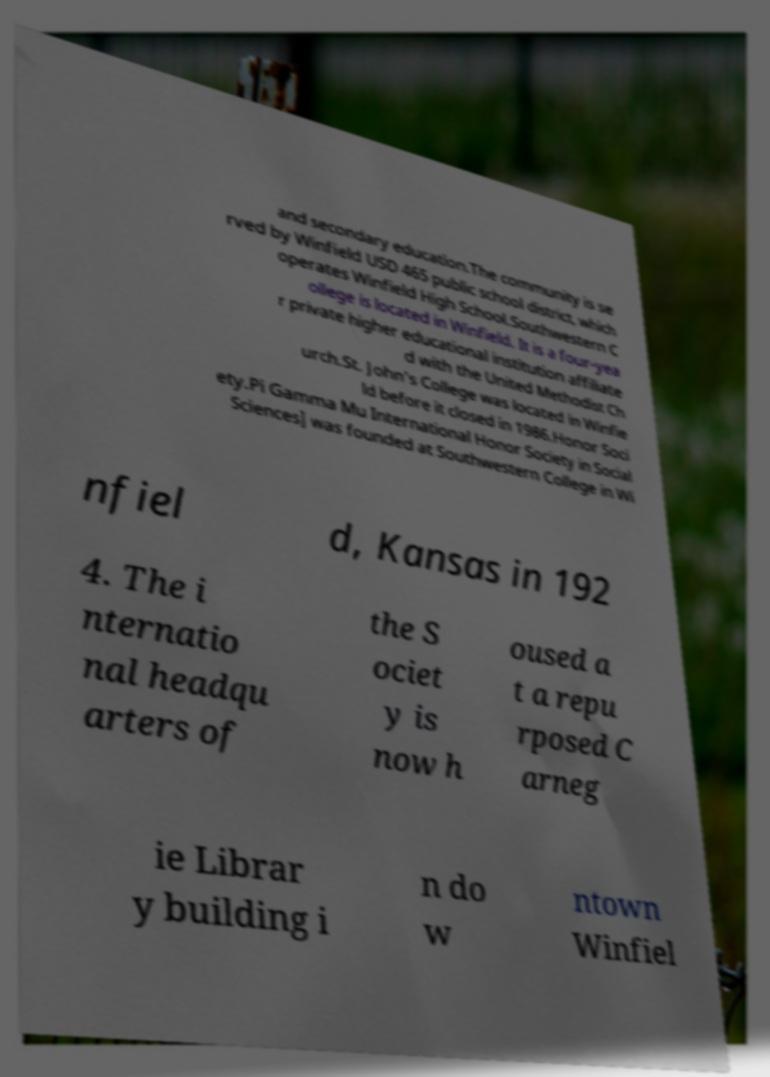Can you accurately transcribe the text from the provided image for me? and secondary education.The community is se rved by Winfield USD 465 public school district, which operates Winfield High School.Southwestern C ollege is located in Winfield. It is a four-yea r private higher educational institution affiliate d with the United Methodist Ch urch.St. John's College was located in Winfie ld before it closed in 1986.Honor Soci ety.Pi Gamma Mu International Honor Society in Social Sciences] was founded at Southwestern College in Wi nfiel d, Kansas in 192 4. The i nternatio nal headqu arters of the S ociet y is now h oused a t a repu rposed C arneg ie Librar y building i n do w ntown Winfiel 